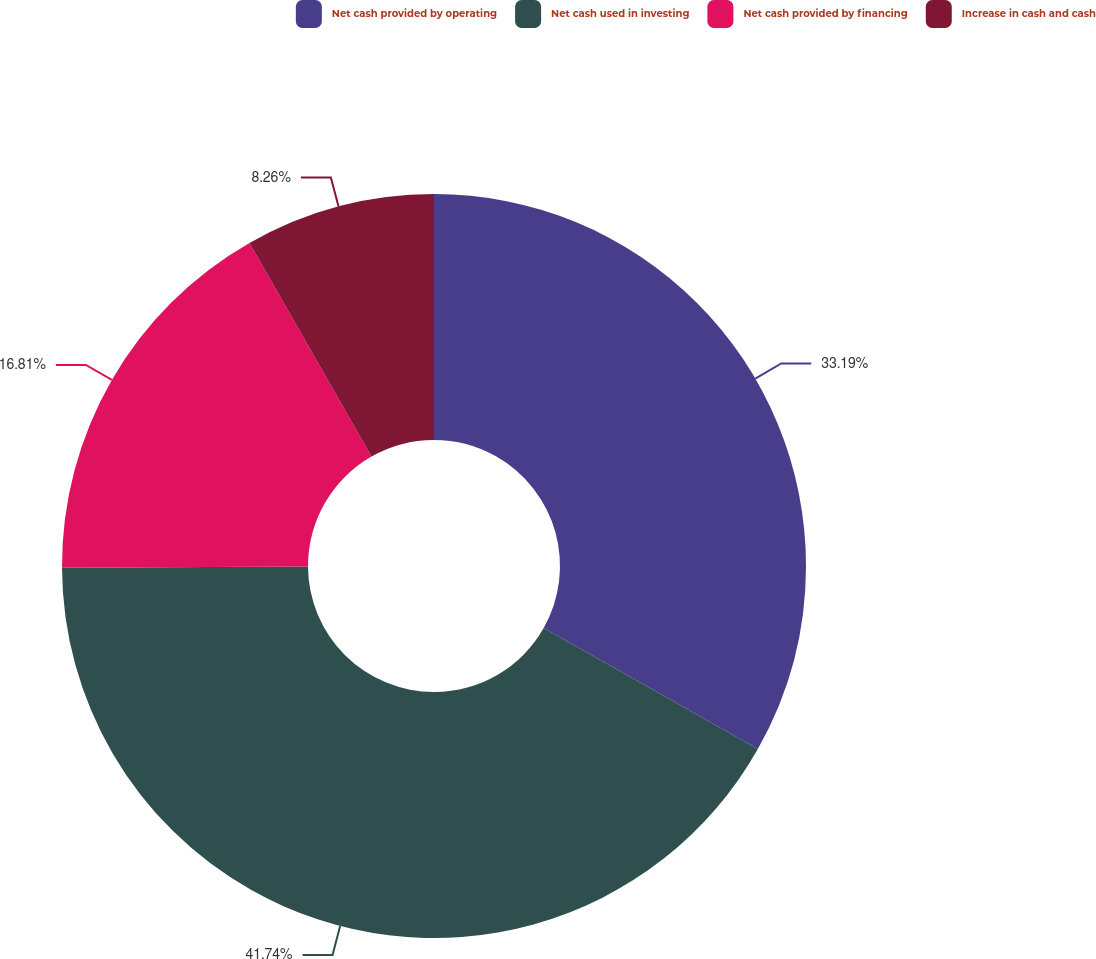Convert chart. <chart><loc_0><loc_0><loc_500><loc_500><pie_chart><fcel>Net cash provided by operating<fcel>Net cash used in investing<fcel>Net cash provided by financing<fcel>Increase in cash and cash<nl><fcel>33.19%<fcel>41.74%<fcel>16.81%<fcel>8.26%<nl></chart> 